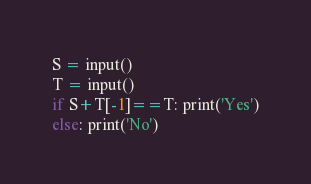<code> <loc_0><loc_0><loc_500><loc_500><_Python_>S = input()
T = input()
if S+T[-1]==T: print('Yes')
else: print('No')</code> 